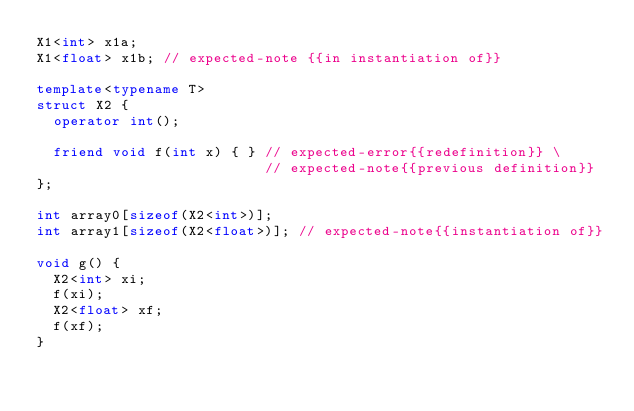Convert code to text. <code><loc_0><loc_0><loc_500><loc_500><_C++_>X1<int> x1a; 
X1<float> x1b; // expected-note {{in instantiation of}}

template<typename T>
struct X2 {
  operator int();

  friend void f(int x) { } // expected-error{{redefinition}} \
                           // expected-note{{previous definition}}
};

int array0[sizeof(X2<int>)]; 
int array1[sizeof(X2<float>)]; // expected-note{{instantiation of}}

void g() {
  X2<int> xi;
  f(xi);
  X2<float> xf; 
  f(xf);
}
</code> 